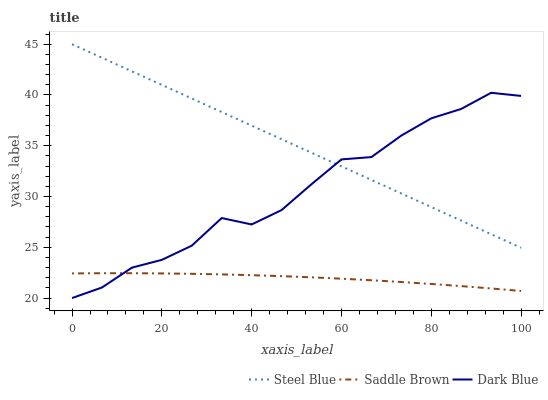Does Saddle Brown have the minimum area under the curve?
Answer yes or no. Yes. Does Steel Blue have the maximum area under the curve?
Answer yes or no. Yes. Does Steel Blue have the minimum area under the curve?
Answer yes or no. No. Does Saddle Brown have the maximum area under the curve?
Answer yes or no. No. Is Steel Blue the smoothest?
Answer yes or no. Yes. Is Dark Blue the roughest?
Answer yes or no. Yes. Is Saddle Brown the smoothest?
Answer yes or no. No. Is Saddle Brown the roughest?
Answer yes or no. No. Does Saddle Brown have the lowest value?
Answer yes or no. No. Does Saddle Brown have the highest value?
Answer yes or no. No. Is Saddle Brown less than Steel Blue?
Answer yes or no. Yes. Is Steel Blue greater than Saddle Brown?
Answer yes or no. Yes. Does Saddle Brown intersect Steel Blue?
Answer yes or no. No. 